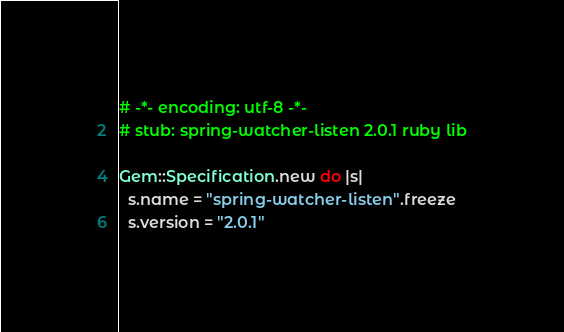<code> <loc_0><loc_0><loc_500><loc_500><_Ruby_># -*- encoding: utf-8 -*-
# stub: spring-watcher-listen 2.0.1 ruby lib

Gem::Specification.new do |s|
  s.name = "spring-watcher-listen".freeze
  s.version = "2.0.1"
</code> 